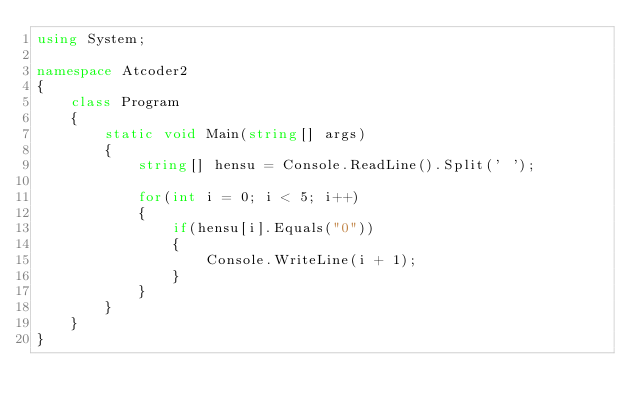<code> <loc_0><loc_0><loc_500><loc_500><_C#_>using System;

namespace Atcoder2
{
    class Program
    {
        static void Main(string[] args)
        {
            string[] hensu = Console.ReadLine().Split(' ');
            
            for(int i = 0; i < 5; i++)
            {
                if(hensu[i].Equals("0"))
                {
                    Console.WriteLine(i + 1);
                }
            }
        }
    }
}</code> 